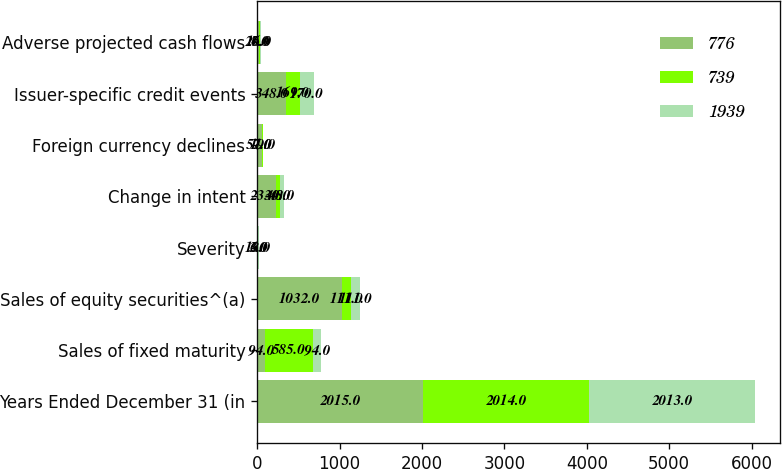Convert chart to OTSL. <chart><loc_0><loc_0><loc_500><loc_500><stacked_bar_chart><ecel><fcel>Years Ended December 31 (in<fcel>Sales of fixed maturity<fcel>Sales of equity securities^(a)<fcel>Severity<fcel>Change in intent<fcel>Foreign currency declines<fcel>Issuer-specific credit events<fcel>Adverse projected cash flows<nl><fcel>776<fcel>2015<fcel>94<fcel>1032<fcel>13<fcel>233<fcel>57<fcel>348<fcel>20<nl><fcel>739<fcel>2014<fcel>585<fcel>111<fcel>3<fcel>40<fcel>19<fcel>169<fcel>16<nl><fcel>1939<fcel>2013<fcel>94<fcel>111<fcel>6<fcel>48<fcel>1<fcel>170<fcel>7<nl></chart> 